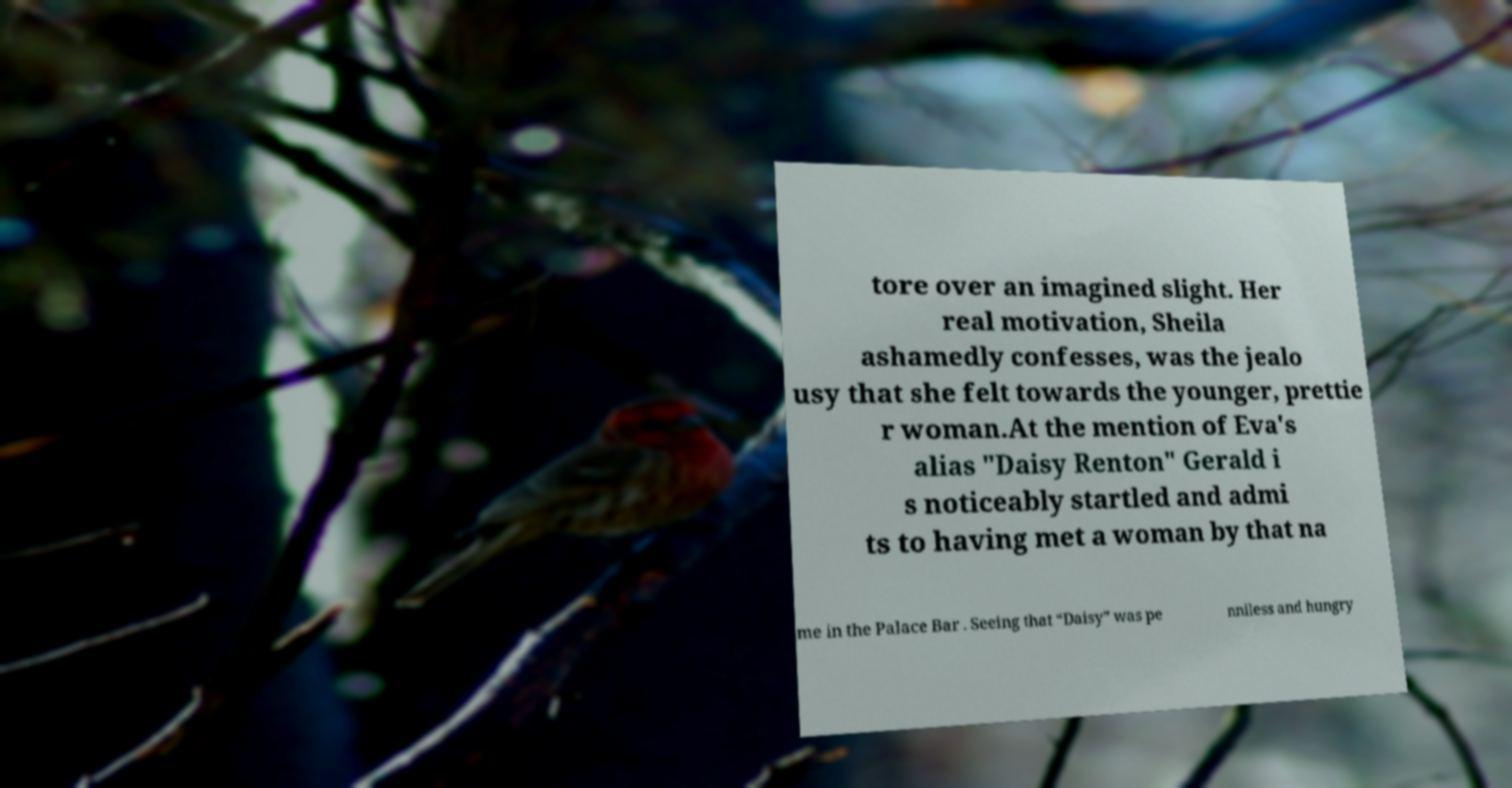For documentation purposes, I need the text within this image transcribed. Could you provide that? tore over an imagined slight. Her real motivation, Sheila ashamedly confesses, was the jealo usy that she felt towards the younger, prettie r woman.At the mention of Eva's alias "Daisy Renton" Gerald i s noticeably startled and admi ts to having met a woman by that na me in the Palace Bar . Seeing that “Daisy” was pe nniless and hungry 